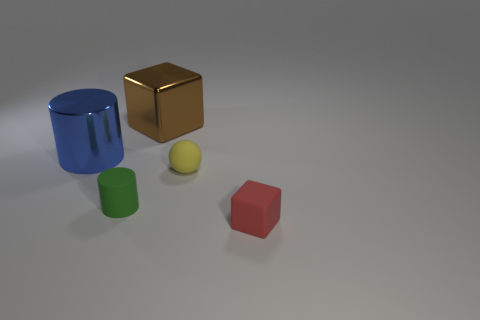Add 4 small brown objects. How many objects exist? 9 Subtract all spheres. How many objects are left? 4 Subtract all tiny red things. Subtract all tiny yellow objects. How many objects are left? 3 Add 5 large metallic blocks. How many large metallic blocks are left? 6 Add 2 tiny purple cylinders. How many tiny purple cylinders exist? 2 Subtract 0 brown cylinders. How many objects are left? 5 